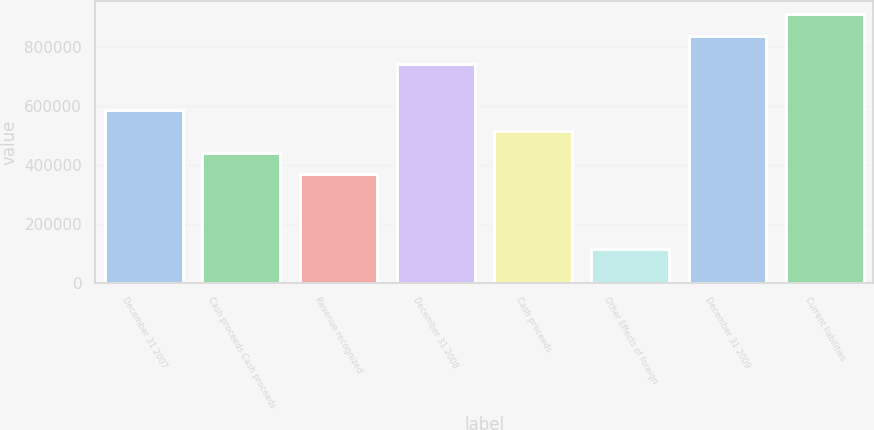<chart> <loc_0><loc_0><loc_500><loc_500><bar_chart><fcel>December 31 2007<fcel>Cash proceeds Cash proceeds<fcel>Revenue recognized<fcel>December 31 2008<fcel>Cash proceeds<fcel>Other Effects of foreign<fcel>December 31 2009<fcel>Current liabilities<nl><fcel>587276<fcel>442331<fcel>369858<fcel>744462<fcel>514804<fcel>115082<fcel>839810<fcel>912283<nl></chart> 